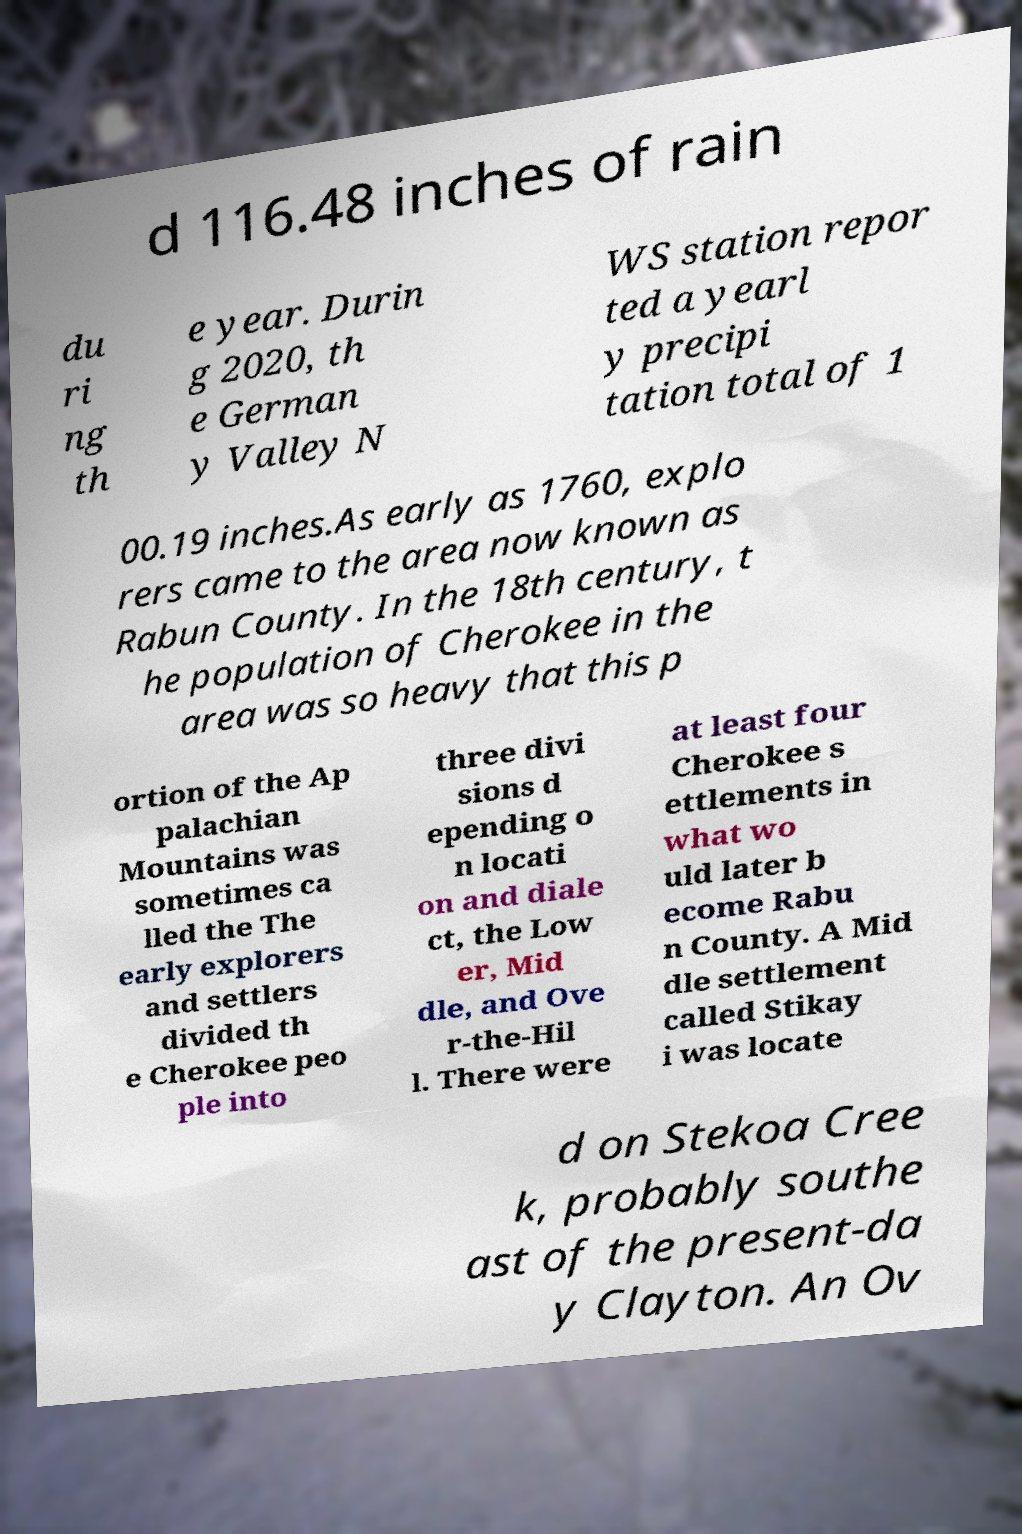Can you accurately transcribe the text from the provided image for me? d 116.48 inches of rain du ri ng th e year. Durin g 2020, th e German y Valley N WS station repor ted a yearl y precipi tation total of 1 00.19 inches.As early as 1760, explo rers came to the area now known as Rabun County. In the 18th century, t he population of Cherokee in the area was so heavy that this p ortion of the Ap palachian Mountains was sometimes ca lled the The early explorers and settlers divided th e Cherokee peo ple into three divi sions d epending o n locati on and diale ct, the Low er, Mid dle, and Ove r-the-Hil l. There were at least four Cherokee s ettlements in what wo uld later b ecome Rabu n County. A Mid dle settlement called Stikay i was locate d on Stekoa Cree k, probably southe ast of the present-da y Clayton. An Ov 